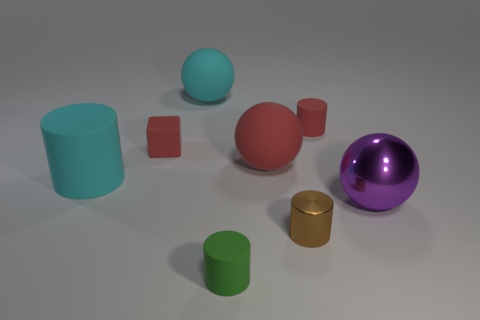Subtract all big rubber spheres. How many spheres are left? 1 Subtract 2 cylinders. How many cylinders are left? 2 Add 1 tiny purple metallic cylinders. How many objects exist? 9 Subtract all purple spheres. How many spheres are left? 2 Subtract all cubes. How many objects are left? 7 Subtract all gray blocks. How many yellow cylinders are left? 0 Subtract all small matte cylinders. Subtract all small matte cylinders. How many objects are left? 4 Add 2 big rubber cylinders. How many big rubber cylinders are left? 3 Add 8 red matte cylinders. How many red matte cylinders exist? 9 Subtract 0 brown blocks. How many objects are left? 8 